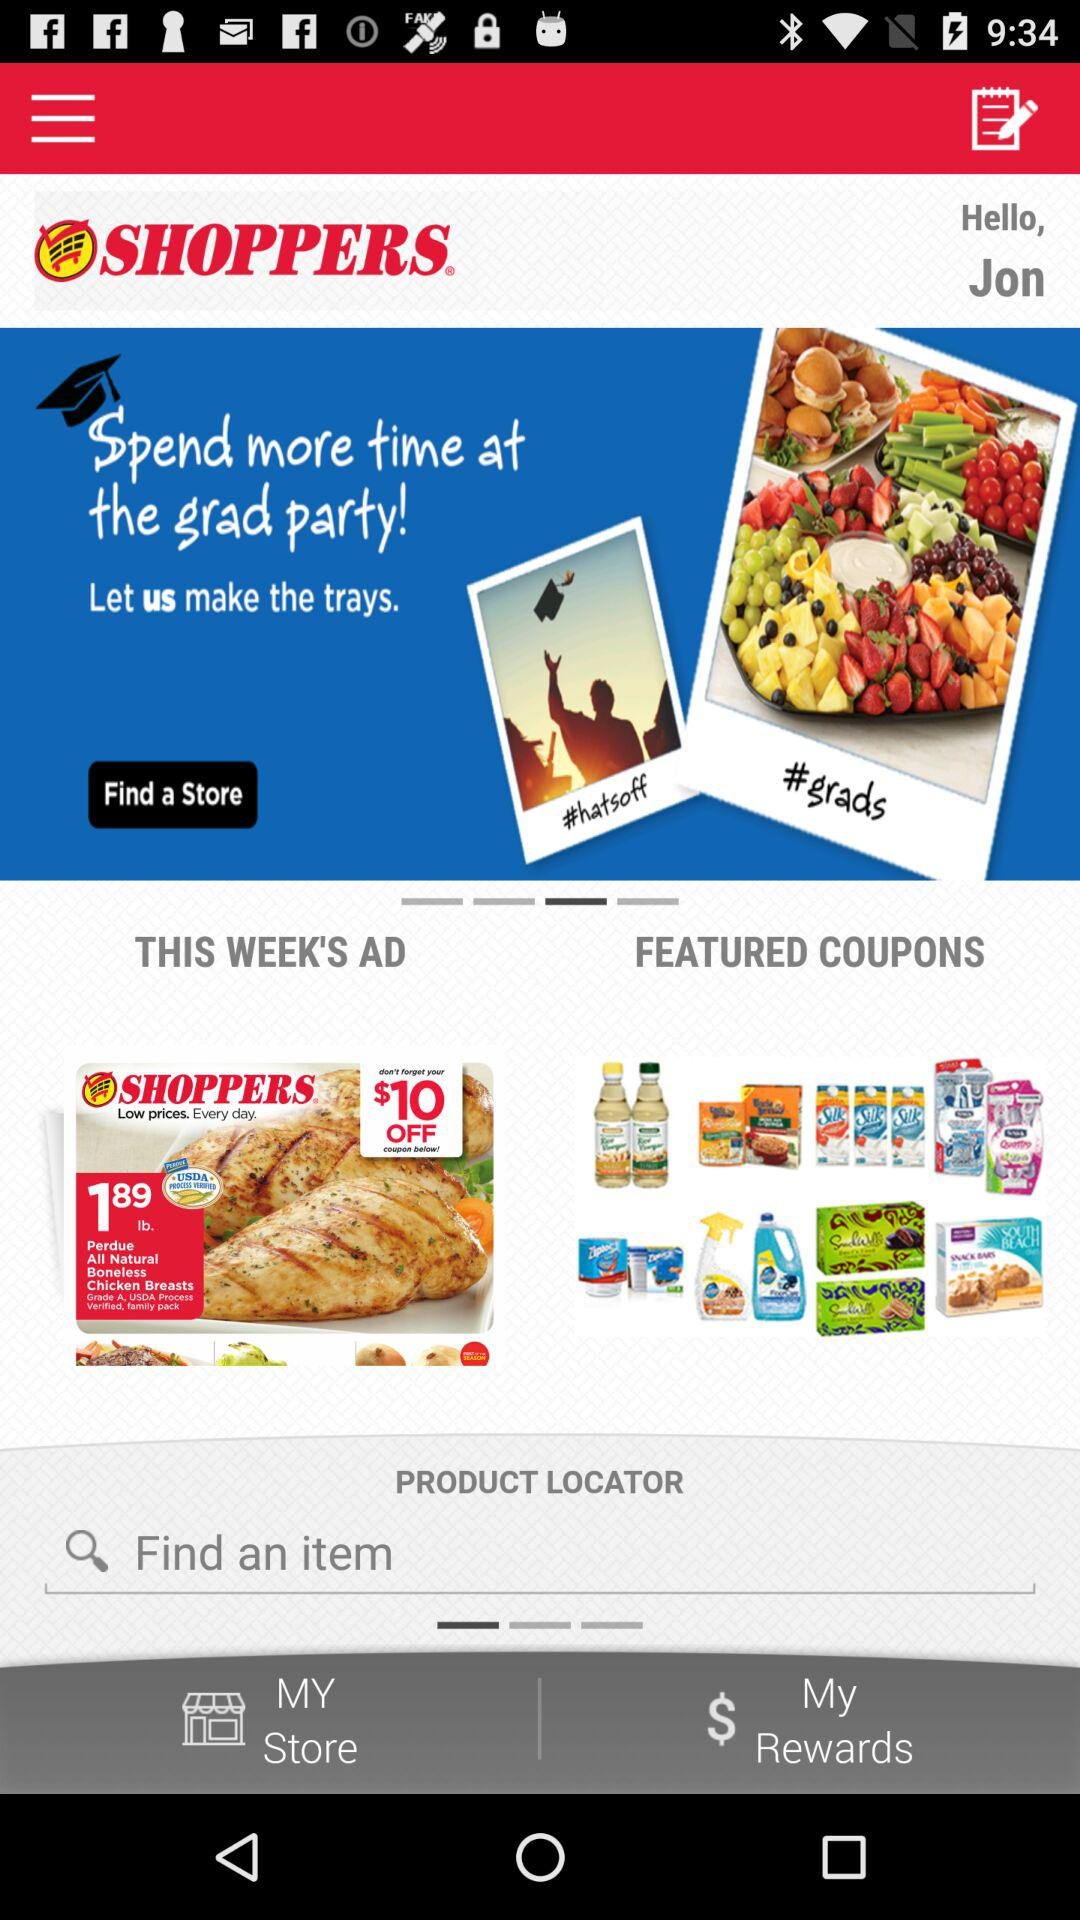What is the user name? The user name is Jon. 